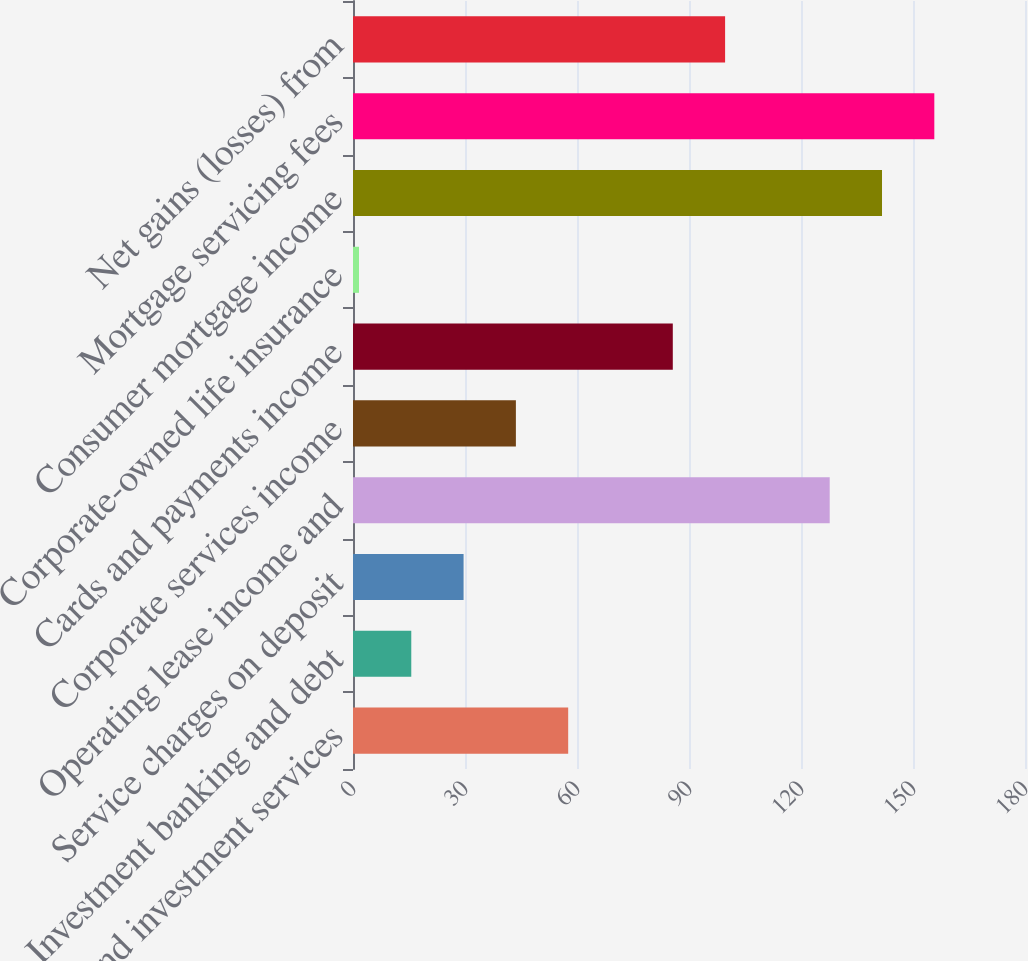Convert chart. <chart><loc_0><loc_0><loc_500><loc_500><bar_chart><fcel>Trust and investment services<fcel>Investment banking and debt<fcel>Service charges on deposit<fcel>Operating lease income and<fcel>Corporate services income<fcel>Cards and payments income<fcel>Corporate-owned life insurance<fcel>Consumer mortgage income<fcel>Mortgage servicing fees<fcel>Net gains (losses) from<nl><fcel>57.64<fcel>15.61<fcel>29.62<fcel>127.69<fcel>43.63<fcel>85.66<fcel>1.6<fcel>141.7<fcel>155.71<fcel>99.67<nl></chart> 